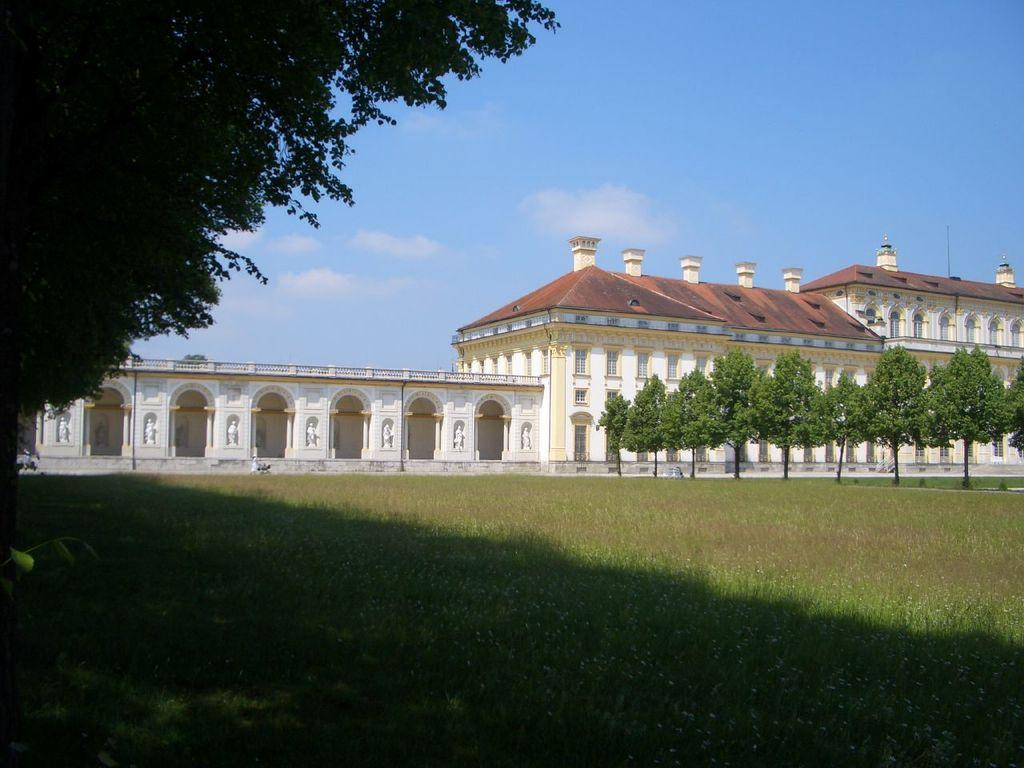What type of vegetation can be seen in the image? There is grass in the image. What other natural elements are present in the image? There are trees in the image. What man-made structures can be seen in the image? There are buildings in the image. What is visible in the background of the image? There are clouds visible in the background of the image. What type of sock is hanging from the tree in the image? There is no sock present in the image; it features grass, trees, buildings, and clouds. How does the crib contribute to the overall composition of the image? There is no crib present in the image. 